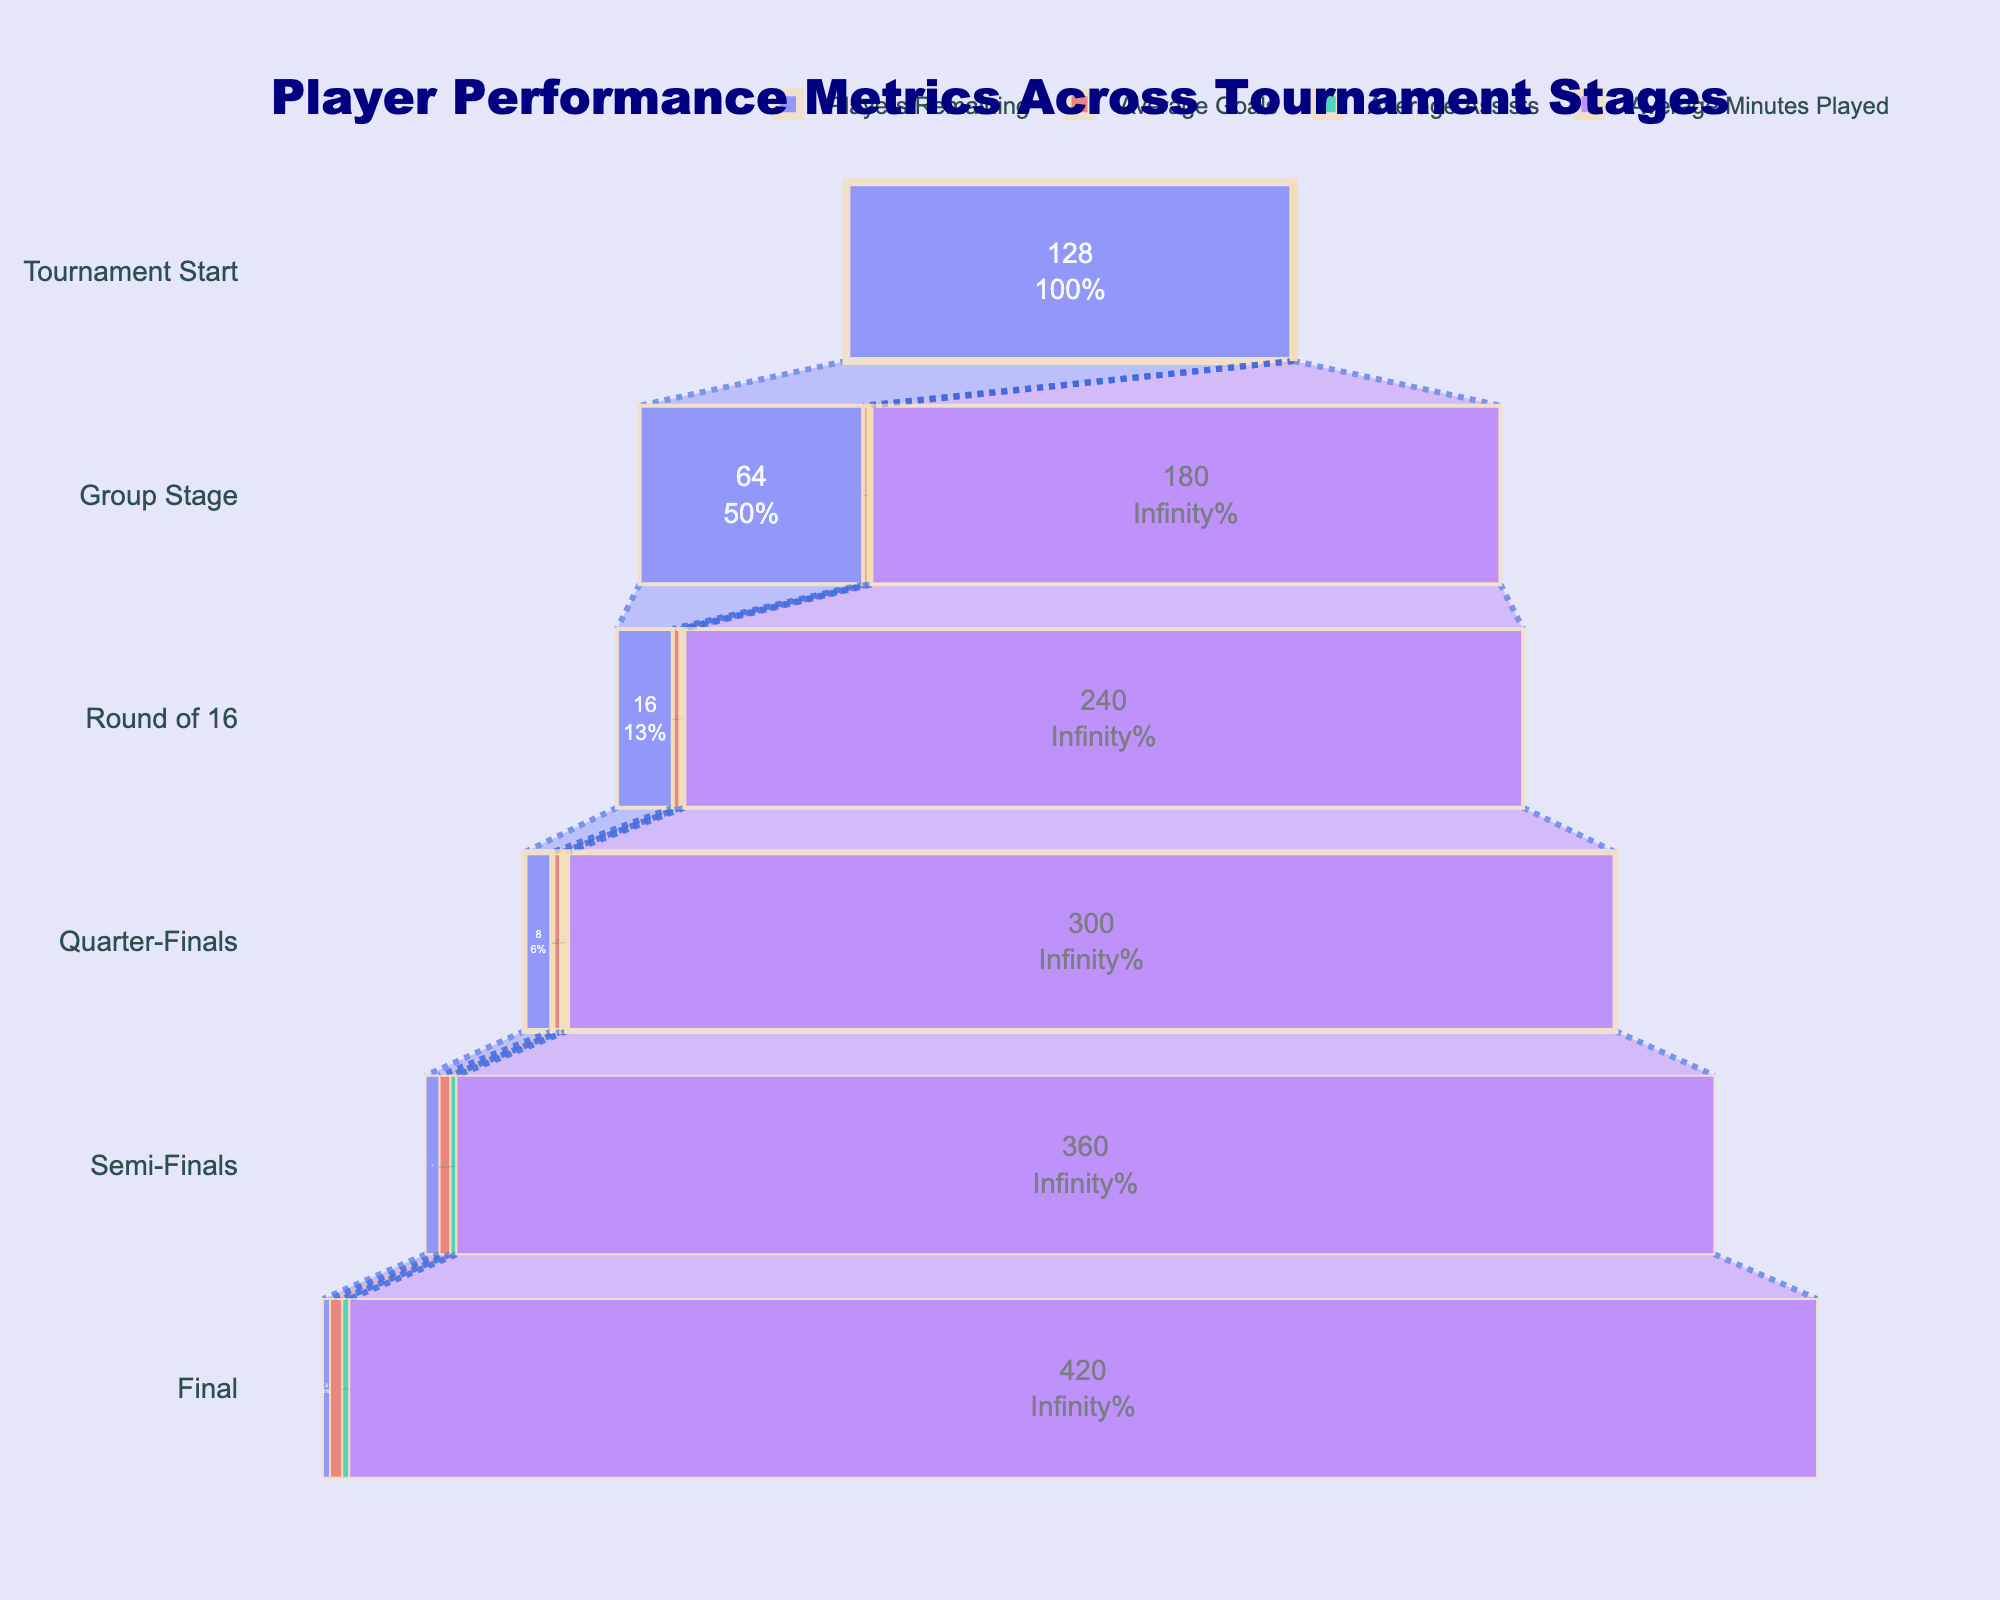How many players remain at the Semi-Finals stage? Referring to the Players Remaining column, the value at the Semi-Finals stage is 4.
Answer: 4 What is the percentage of players that advance from the Group Stage to the Round of 16? There are 64 players at the Group Stage and 16 players at the Round of 16. The percentage is (16 / 64) * 100%.
Answer: 25% How much does the average number of goals increase from the Quarter-Finals to the Final? The average goals at the Quarter-Finals is 2.8 and at the Final is 3.5. The increase is 3.5 - 2.8.
Answer: 0.7 Between which stages is there the largest drop in the number of players? Look at the Players Remaining column and identify the biggest difference: from Group Stage (64) to Round of 16 (16), which is a drop of 48 players.
Answer: Group Stage to Round of 16 What is the average number of assists for players who made it to at least the Semi-Finals? The Semi-Finals Average Assists is 1.7 and the Final Average Assists is 2.0. To find the average: (1.7 + 2.0) / 2.
Answer: 1.85 How many more average minutes are played in the Final compared to the Group Stage? The average minutes at the Group Stage is 180, and at the Final is 420. The difference is 420 - 180.
Answer: 240 Is there a stage where the average goals remain constant? By examining Average Goals across stages, we see that there is no stage where it remains constant; it increases at every stage.
Answer: No In which stage do players have the highest average number of assists? Referring to the Average Assists column, the highest value is at the Final stage (2.0).
Answer: Final How does the number of players change between Tournament Start and Group Stage? There are 128 players at the Tournament Start and 64 players at the Group Stage. The number of players decreases by 128 - 64.
Answer: 64 Which metric shows the smallest increase from the Quarter-Finals to the Semi-Finals? Comparing the changes: Average Goals (3.1 - 2.8 = 0.3), Average Assists (1.7 - 1.4 = 0.3), Average Minutes Played (360 - 300 = 60). Goals and Assists both increase by 0.3.
Answer: Average Goals and Assists 